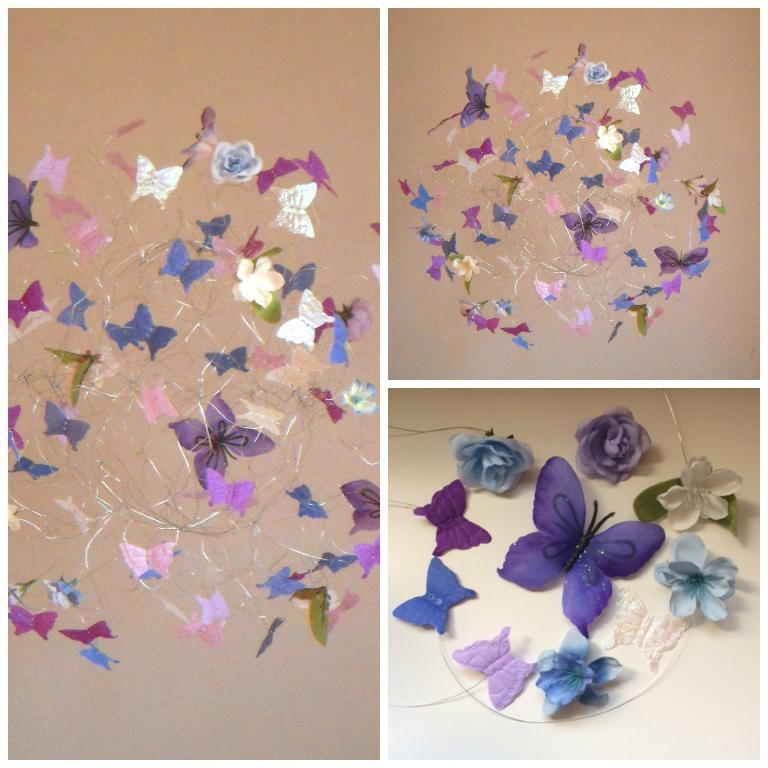What type of artwork is depicted in the image? The image is a collage. What elements are included in the collage? There are wires with butterflies and flowers in the image. What can be seen in the background of the collage? There are walls visible in the background of the image. What type of doll is sitting on the table in the image? There is no doll present in the image; it is a collage featuring wires with butterflies and flowers. What type of flesh can be seen in the image? There is no flesh visible in the image; it is a collage featuring wires with butterflies and flowers. 